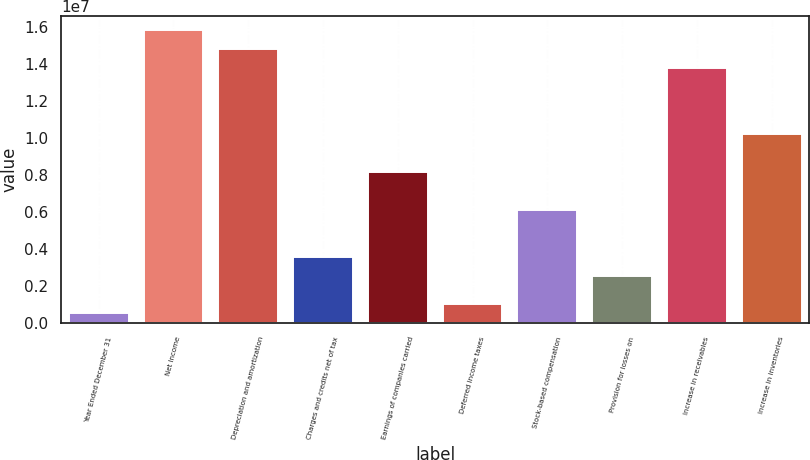Convert chart. <chart><loc_0><loc_0><loc_500><loc_500><bar_chart><fcel>Year Ended December 31<fcel>Net Income<fcel>Depreciation and amortization<fcel>Charges and credits net of tax<fcel>Earnings of companies carried<fcel>Deferred income taxes<fcel>Stock-based compensation<fcel>Provision for losses on<fcel>Increase in receivables<fcel>Increase in inventories<nl><fcel>509962<fcel>1.57992e+07<fcel>1.47799e+07<fcel>3.56781e+06<fcel>8.15458e+06<fcel>1.0196e+06<fcel>6.11601e+06<fcel>2.54853e+06<fcel>1.37606e+07<fcel>1.01931e+07<nl></chart> 